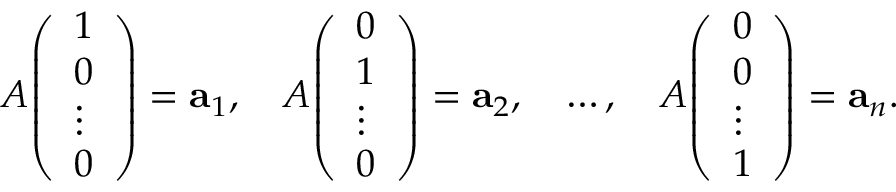<formula> <loc_0><loc_0><loc_500><loc_500>A { \left ( \begin{array} { l } { 1 } \\ { 0 } \\ { \vdots } \\ { 0 } \end{array} \right ) } = a _ { 1 } , \quad A { \left ( \begin{array} { l } { 0 } \\ { 1 } \\ { \vdots } \\ { 0 } \end{array} \right ) } = a _ { 2 } , \quad \dots , \quad A { \left ( \begin{array} { l } { 0 } \\ { 0 } \\ { \vdots } \\ { 1 } \end{array} \right ) } = a _ { n } .</formula> 